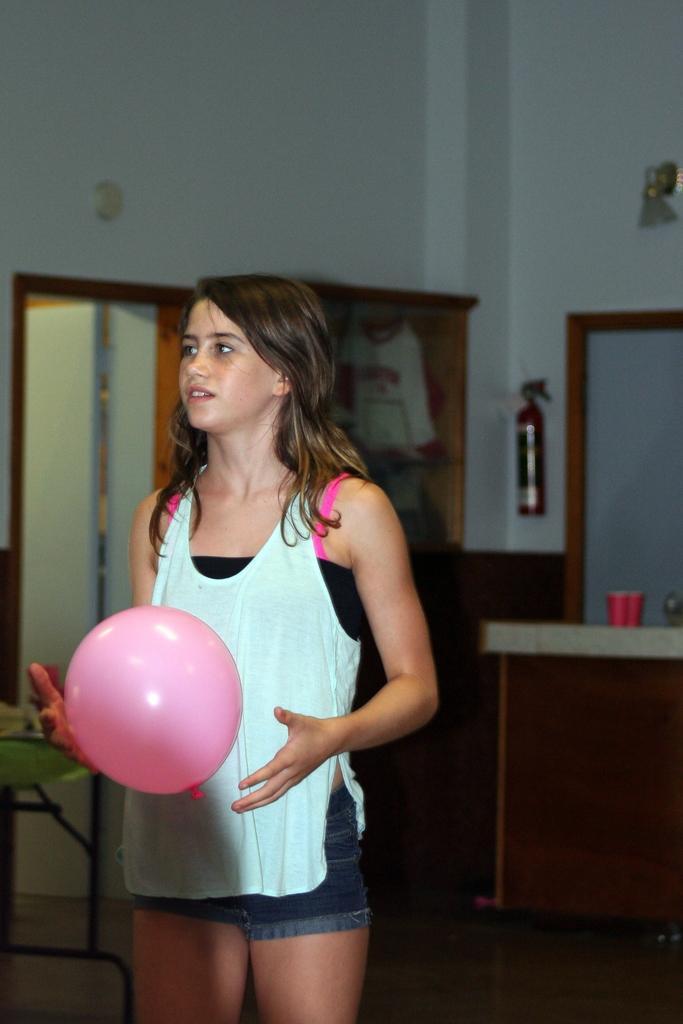How would you summarize this image in a sentence or two? In this picture there is a woman who is holding a pink color balloon. She is standing near to the table. In the back I can see the cup on the platform. Beside that I can see the fire hydrant near to the door and shelves. 